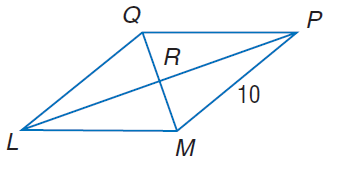Answer the mathemtical geometry problem and directly provide the correct option letter.
Question: In rhombus L M P Q, m \angle Q L M = 2 x^ { 2 } - 10, m \angle Q P M = 8 x, and M P = 10. Find m \angle L P Q.
Choices: A: 20 B: 30 C: 45 D: 60 A 